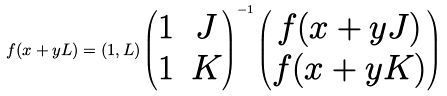<formula> <loc_0><loc_0><loc_500><loc_500>f ( x + y L ) = ( 1 , L ) \left ( \begin{matrix} 1 & J \\ 1 & K \end{matrix} \right ) ^ { - 1 } \left ( \begin{matrix} f ( x + y J ) \\ f ( x + y K ) \end{matrix} \right )</formula> 